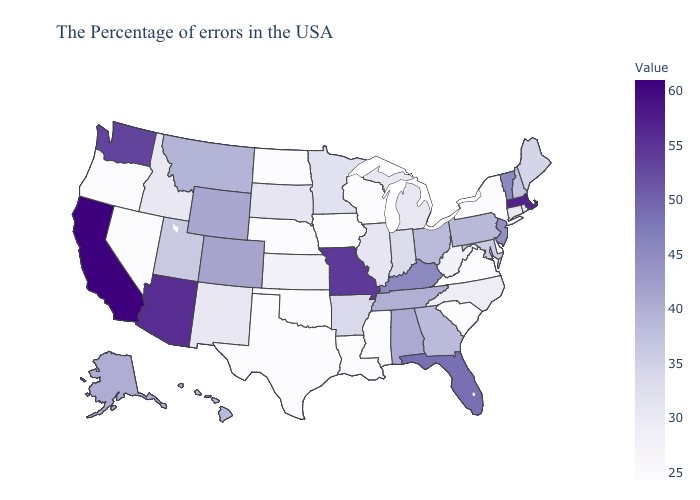Which states hav the highest value in the South?
Quick response, please. Florida. Does Minnesota have the highest value in the MidWest?
Write a very short answer. No. Does the map have missing data?
Answer briefly. No. Does Oklahoma have a higher value than South Dakota?
Short answer required. No. Does New York have the lowest value in the Northeast?
Concise answer only. Yes. Does North Dakota have a lower value than Alaska?
Quick response, please. Yes. 